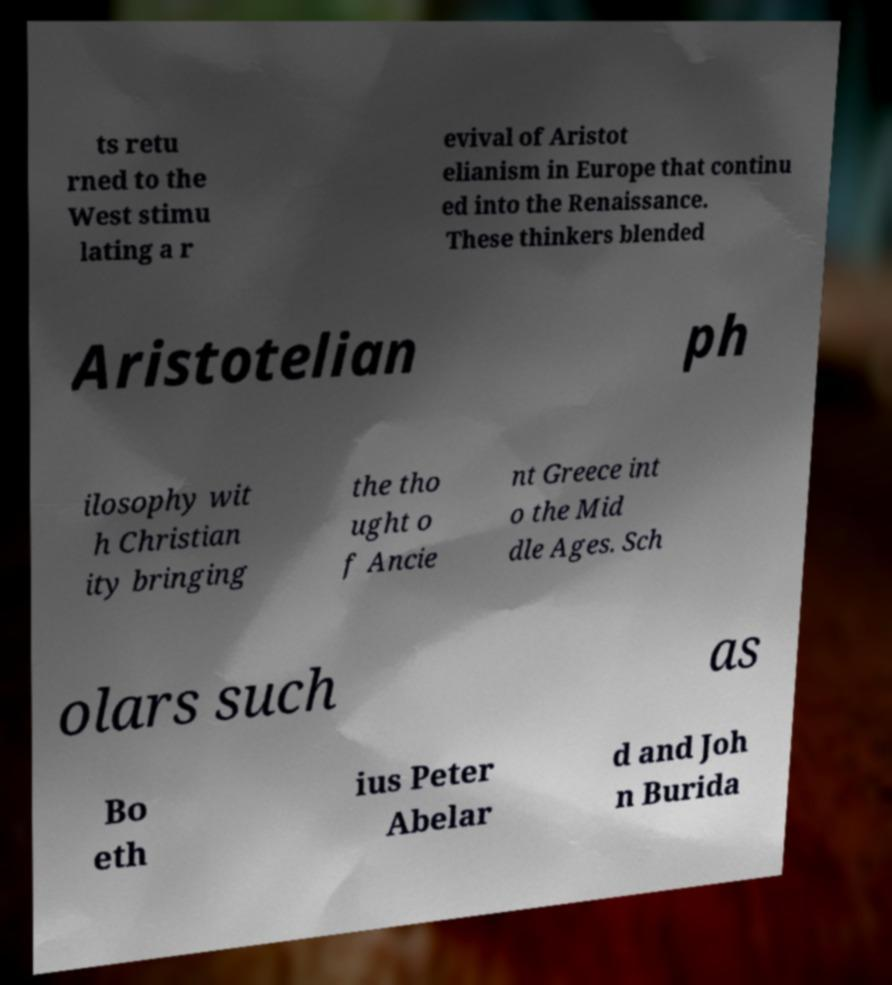I need the written content from this picture converted into text. Can you do that? ts retu rned to the West stimu lating a r evival of Aristot elianism in Europe that continu ed into the Renaissance. These thinkers blended Aristotelian ph ilosophy wit h Christian ity bringing the tho ught o f Ancie nt Greece int o the Mid dle Ages. Sch olars such as Bo eth ius Peter Abelar d and Joh n Burida 